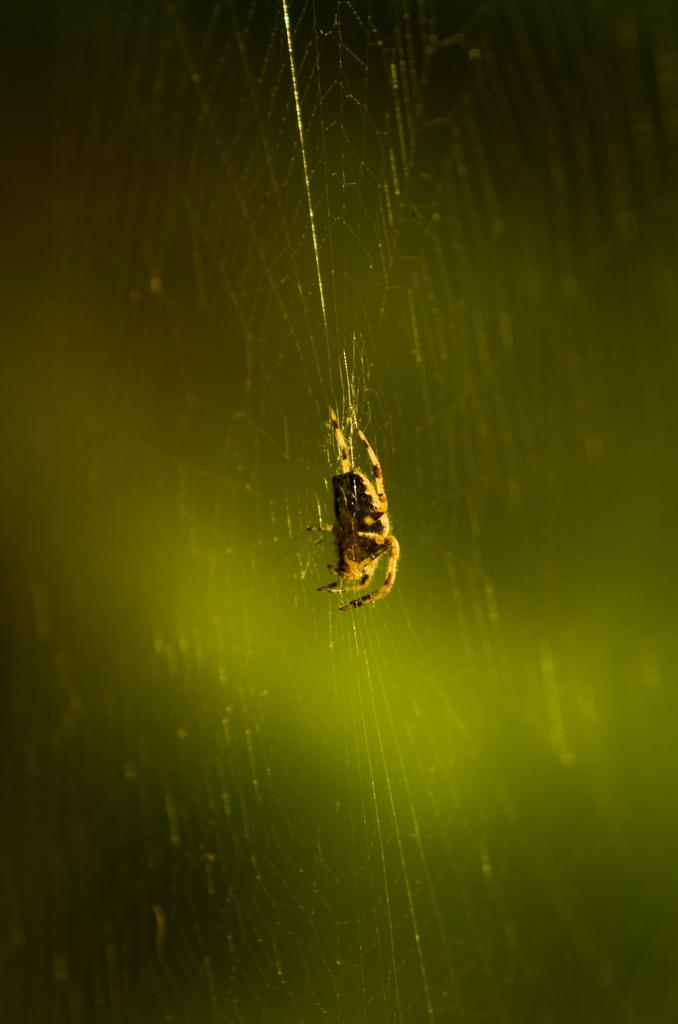What is the main subject of the image? There is a spider in the image. Where is the spider located? The spider is on a spider web. What color is the background of the image? The background of the image appears green. What type of sign can be seen in the image? There is no sign present in the image; it features a spider on a spider web with a green background. Can you see a cow in the image? There is no cow present in the image. 